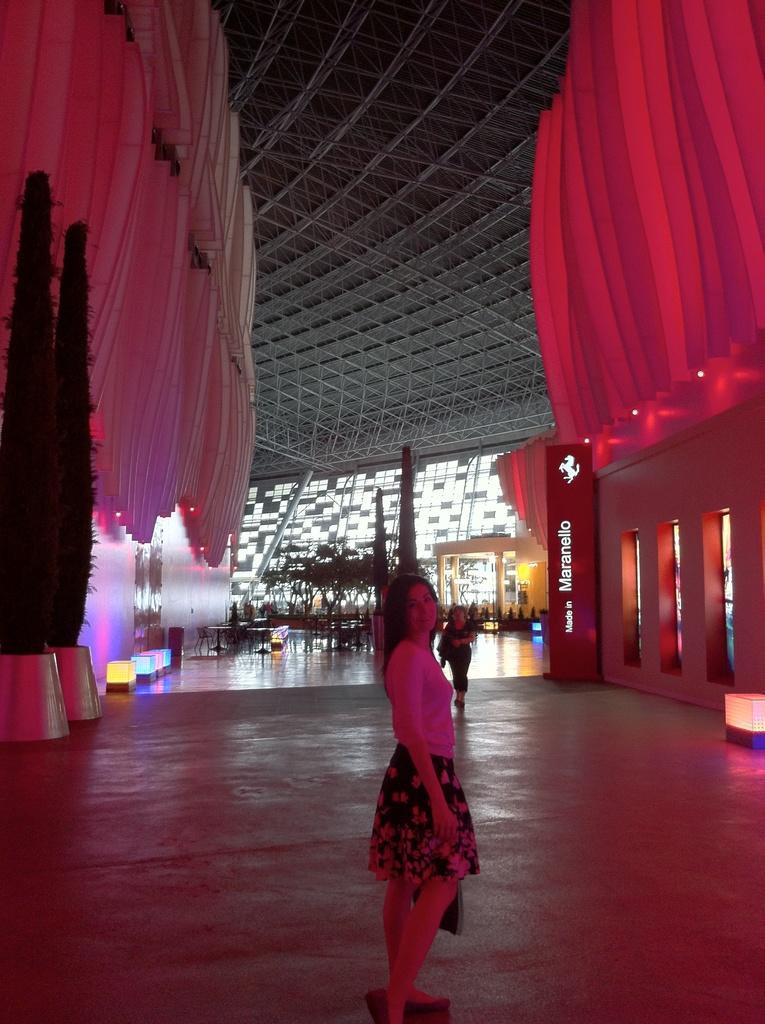Please provide a concise description of this image. In the image we can see there are people standing on the floor and there are trees kept in a pot. Behind there is decorative interior in the building. 